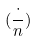Convert formula to latex. <formula><loc_0><loc_0><loc_500><loc_500>( \frac { \cdot } { n } )</formula> 